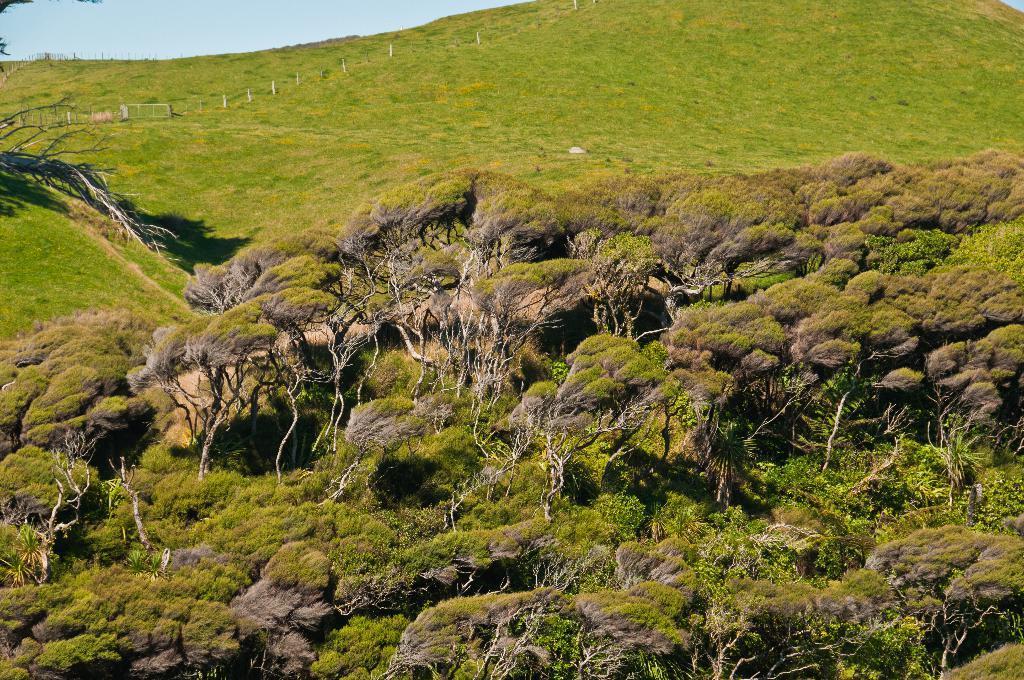How would you summarize this image in a sentence or two? In this image we can see trees, grass and poles. On the left side top of the image there is the sky. At the bottom of the image there are trees. 